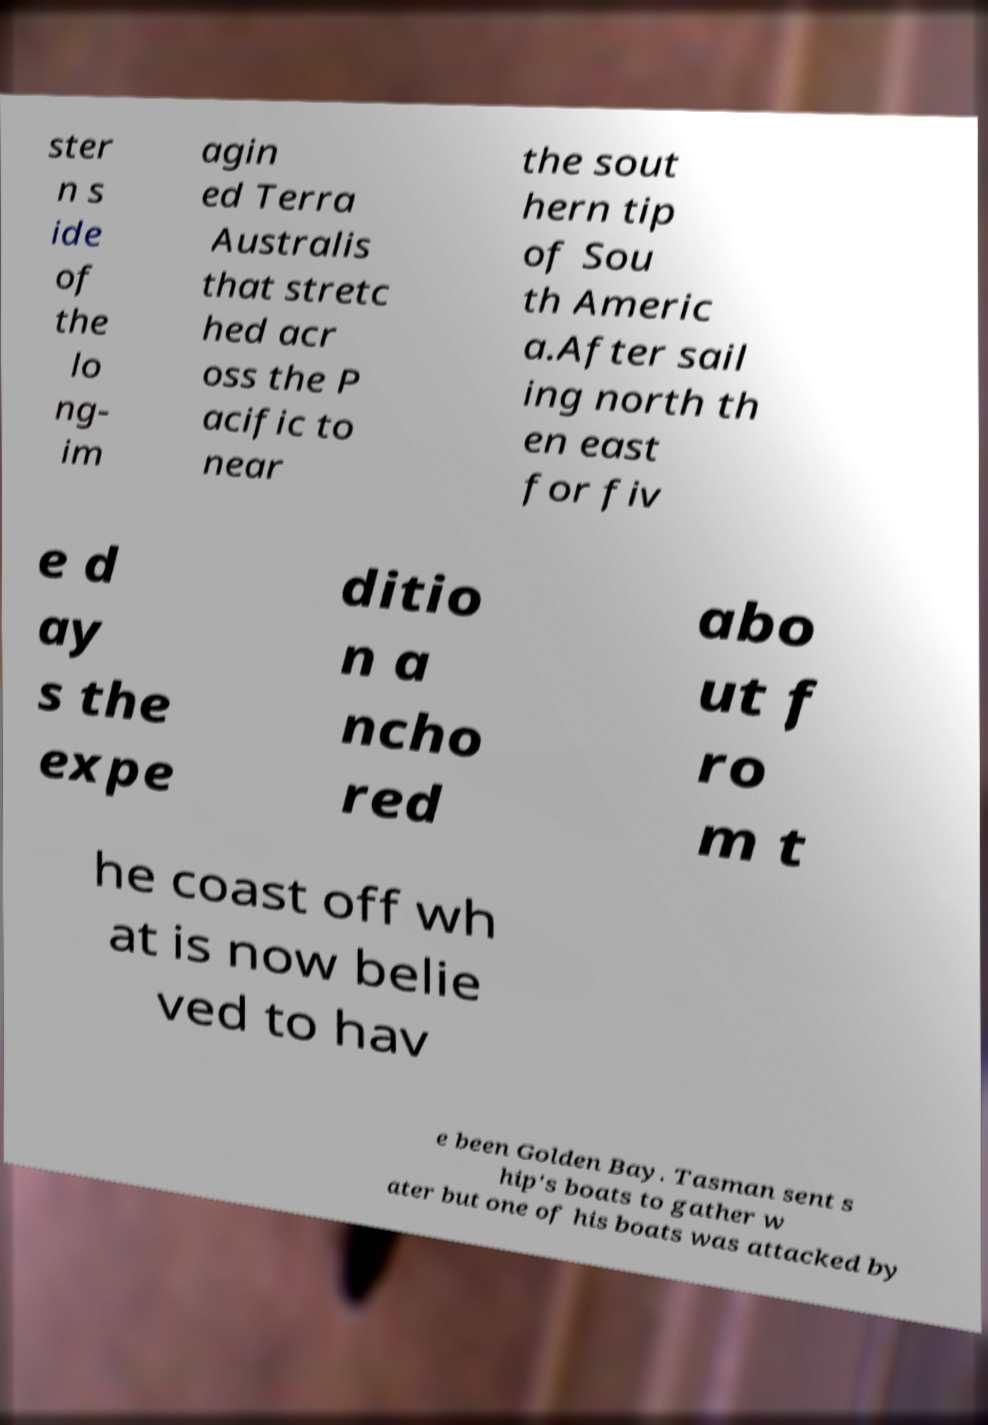There's text embedded in this image that I need extracted. Can you transcribe it verbatim? ster n s ide of the lo ng- im agin ed Terra Australis that stretc hed acr oss the P acific to near the sout hern tip of Sou th Americ a.After sail ing north th en east for fiv e d ay s the expe ditio n a ncho red abo ut f ro m t he coast off wh at is now belie ved to hav e been Golden Bay. Tasman sent s hip's boats to gather w ater but one of his boats was attacked by 